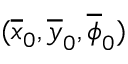<formula> <loc_0><loc_0><loc_500><loc_500>( \overline { x } _ { 0 } , \overline { y } _ { 0 } , \overline { \phi } _ { 0 } )</formula> 